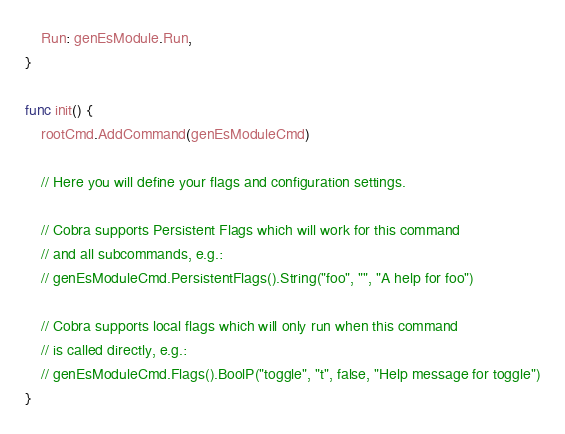Convert code to text. <code><loc_0><loc_0><loc_500><loc_500><_Go_>	Run: genEsModule.Run,
}

func init() {
	rootCmd.AddCommand(genEsModuleCmd)

	// Here you will define your flags and configuration settings.

	// Cobra supports Persistent Flags which will work for this command
	// and all subcommands, e.g.:
	// genEsModuleCmd.PersistentFlags().String("foo", "", "A help for foo")

	// Cobra supports local flags which will only run when this command
	// is called directly, e.g.:
	// genEsModuleCmd.Flags().BoolP("toggle", "t", false, "Help message for toggle")
}
</code> 